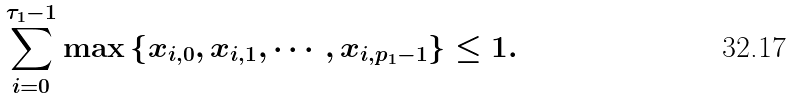Convert formula to latex. <formula><loc_0><loc_0><loc_500><loc_500>\sum _ { i = 0 } ^ { \tau _ { 1 } - 1 } \max \left \{ x _ { i , 0 } , x _ { i , 1 } , \cdots , x _ { i , p _ { 1 } - 1 } \right \} \leq 1 .</formula> 